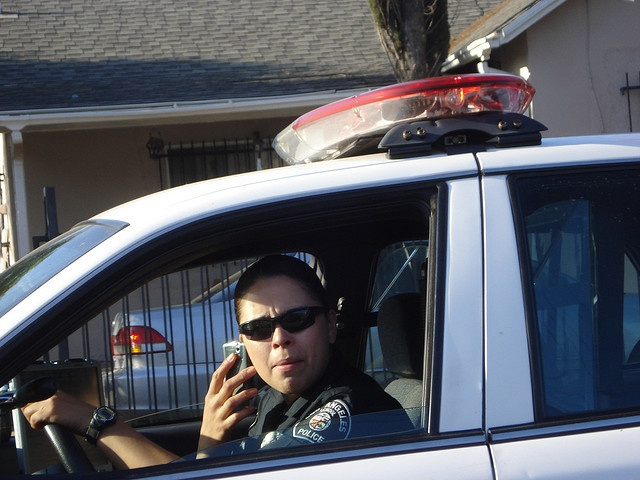Describe the objects in this image and their specific colors. I can see car in gray, black, lightgray, darkgray, and navy tones, people in gray, black, maroon, and tan tones, tv in gray, black, maroon, and purple tones, and cell phone in gray, black, darkgray, and white tones in this image. 